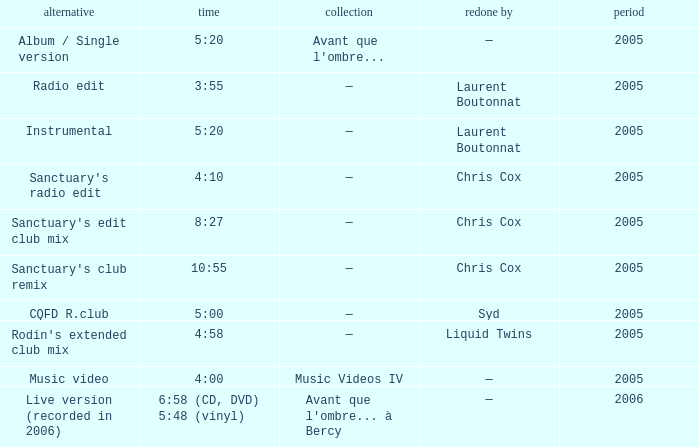What is the version shown for the Length of 4:58? Rodin's extended club mix. 